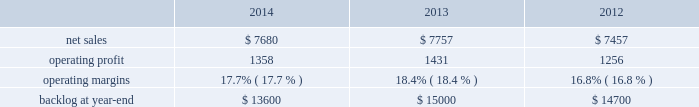Is&gs 2019 operating profit decreased $ 60 million , or 8% ( 8 % ) , for 2014 compared to 2013 .
The decrease was primarily attributable to the activities mentioned above for sales , lower risk retirements and reserves recorded on an international program , partially offset by severance recoveries related to the restructuring announced in november 2013 of approximately $ 20 million for 2014 .
Adjustments not related to volume , including net profit booking rate adjustments , were approximately $ 30 million lower for 2014 compared to 2013 .
2013 compared to 2012 is&gs 2019 net sales decreased $ 479 million , or 5% ( 5 % ) , for 2013 compared to 2012 .
The decrease was attributable to lower net sales of about $ 495 million due to decreased volume on various programs ( command and control programs for classified customers , ngi and eram programs ) ; and approximately $ 320 million due to the completion of certain programs ( such as total information processing support services , the transportation worker identification credential and the outsourcing desktop initiative for nasa ) .
The decrease was partially offset by higher net sales of about $ 340 million due to the start-up of certain programs ( such as the disa gsm-o and the national science foundation antarctic support ) .
Is&gs 2019 operating profit decreased $ 49 million , or 6% ( 6 % ) , for 2013 compared to 2012 .
The decrease was primarily attributable to lower operating profit of about $ 55 million due to certain programs nearing the end of their life cycles , partially offset by higher operating profit of approximately $ 15 million due to the start-up of certain programs .
Adjustments not related to volume , including net profit booking rate adjustments and other matters , were comparable for 2013 compared to 2012 .
Backlog backlog increased in 2014 compared to 2013 primarily due to several multi-year international awards and various u.s .
Multi-year extensions .
This increase was partially offset by declining activities on various direct warfighter support and command and control programs impacted by defense budget reductions .
Backlog decreased in 2013 compared to 2012 primarily due to lower orders on several programs ( such as eram and ngi ) , higher sales on certain programs ( the national science foundation antarctic support and the disa gsm-o ) and declining activities on several smaller programs primarily due to the continued downturn in federal information technology budgets .
Trends we expect is&gs 2019 net sales to decline in 2015 in the low to mid single digit percentage range as compared to 2014 , primarily driven by the continued downturn in federal information technology budgets , an increasingly competitive environment , including the disaggregation of existing contracts , and new contract award delays , partially offset by increased sales resulting from acquisitions that occurred during the year .
Operating profit is expected to decline in the low double digit percentage range in 2015 primarily driven by volume and an increase in intangible amortization from 2014 acquisition activity , resulting in 2015 margins that are lower than 2014 results .
Missiles and fire control our mfc business segment provides air and missile defense systems ; tactical missiles and air-to-ground precision strike weapon systems ; logistics and other technical services ; fire control systems ; mission operations support , readiness , engineering support and integration services ; and manned and unmanned ground vehicles .
Mfc 2019s major programs include pac-3 , thaad , multiple launch rocket system , hellfire , jassm , javelin , apache , sniper ae , low altitude navigation and targeting infrared for night ( lantirn ae ) and sof clss .
Mfc 2019s operating results included the following ( in millions ) : .
2014 compared to 2013 mfc 2019s net sales for 2014 decreased $ 77 million , or 1% ( 1 % ) , compared to 2013 .
The decrease was primarily attributable to lower net sales of approximately $ 385 million for technical services programs due to decreased volume reflecting market pressures ; and about $ 115 million for tactical missile programs due to fewer deliveries ( primarily high mobility artillery .
What is the growth rate in operating profit for mfc in 2014? 
Computations: ((1358 - 1431) / 1431)
Answer: -0.05101. 